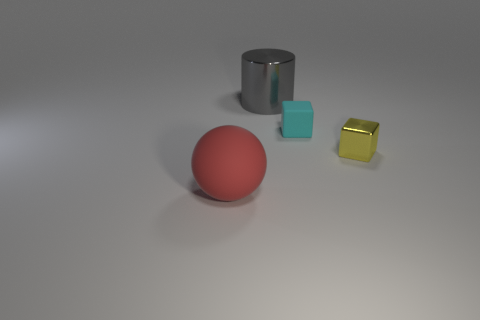Add 3 large green cubes. How many objects exist? 7 Subtract all cylinders. How many objects are left? 3 Subtract 0 green cubes. How many objects are left? 4 Subtract all purple metal blocks. Subtract all red matte things. How many objects are left? 3 Add 3 yellow things. How many yellow things are left? 4 Add 1 tiny cyan cubes. How many tiny cyan cubes exist? 2 